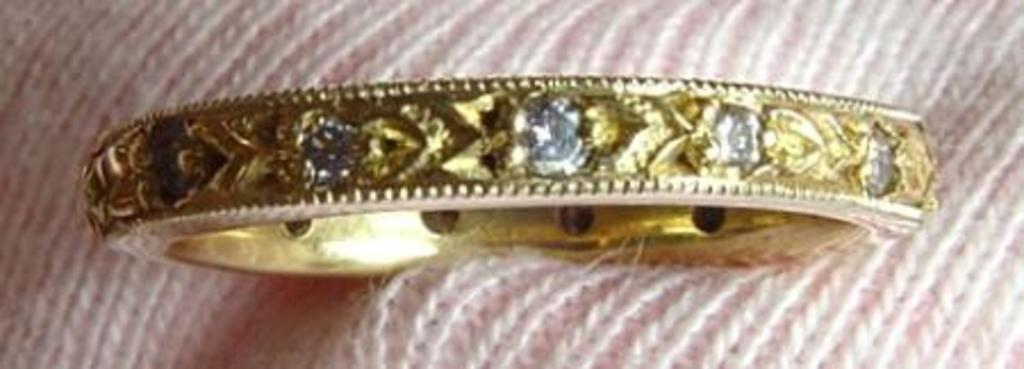What type of material is the cloth in the image made of? The cloth in the image is made of wool. What color is the woolen cloth? The cloth is pink in color. What accessory is placed on the cloth? There is a golden bangle on the cloth. How much payment is required for the cabbage in the image? There is no cabbage present in the image, so it is not possible to determine the payment required. 